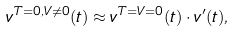Convert formula to latex. <formula><loc_0><loc_0><loc_500><loc_500>v ^ { T = 0 , V \neq 0 } ( t ) \approx v ^ { T = V = 0 } ( t ) \cdot v ^ { \prime } ( t ) ,</formula> 